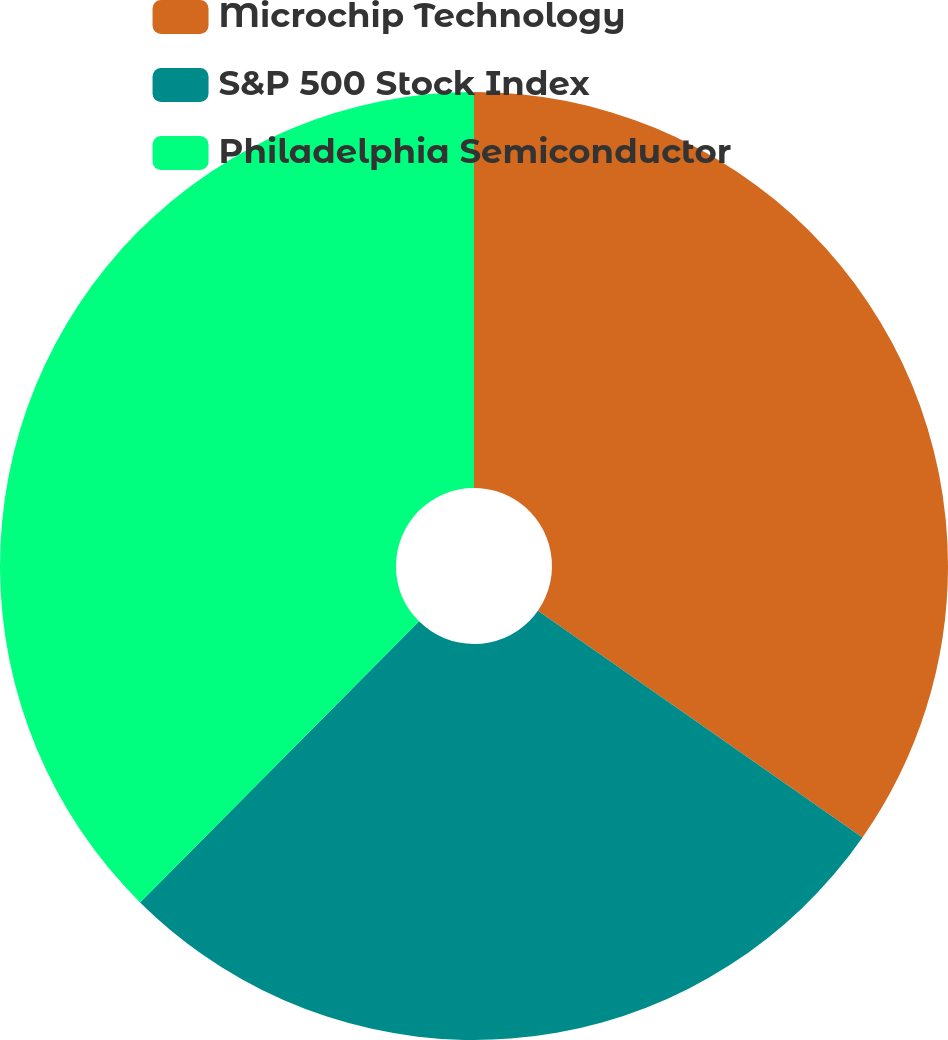Convert chart to OTSL. <chart><loc_0><loc_0><loc_500><loc_500><pie_chart><fcel>Microchip Technology<fcel>S&P 500 Stock Index<fcel>Philadelphia Semiconductor<nl><fcel>34.71%<fcel>27.73%<fcel>37.56%<nl></chart> 